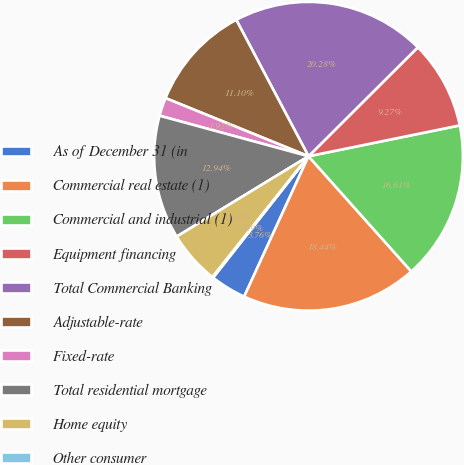Convert chart. <chart><loc_0><loc_0><loc_500><loc_500><pie_chart><fcel>As of December 31 (in<fcel>Commercial real estate (1)<fcel>Commercial and industrial (1)<fcel>Equipment financing<fcel>Total Commercial Banking<fcel>Adjustable-rate<fcel>Fixed-rate<fcel>Total residential mortgage<fcel>Home equity<fcel>Other consumer<nl><fcel>3.76%<fcel>18.44%<fcel>16.61%<fcel>9.27%<fcel>20.28%<fcel>11.1%<fcel>1.92%<fcel>12.94%<fcel>5.6%<fcel>0.09%<nl></chart> 